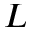<formula> <loc_0><loc_0><loc_500><loc_500>L</formula> 